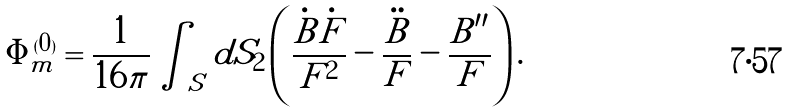<formula> <loc_0><loc_0><loc_500><loc_500>\Phi ^ { ( 0 ) } _ { m } = \frac { 1 } { 1 6 \pi } \int _ { S } d S _ { 2 } \left ( \frac { \dot { B } \dot { F } } { F ^ { 2 } } - \frac { \ddot { B } } { F } - \frac { B ^ { \prime \prime } } { F } \right ) .</formula> 